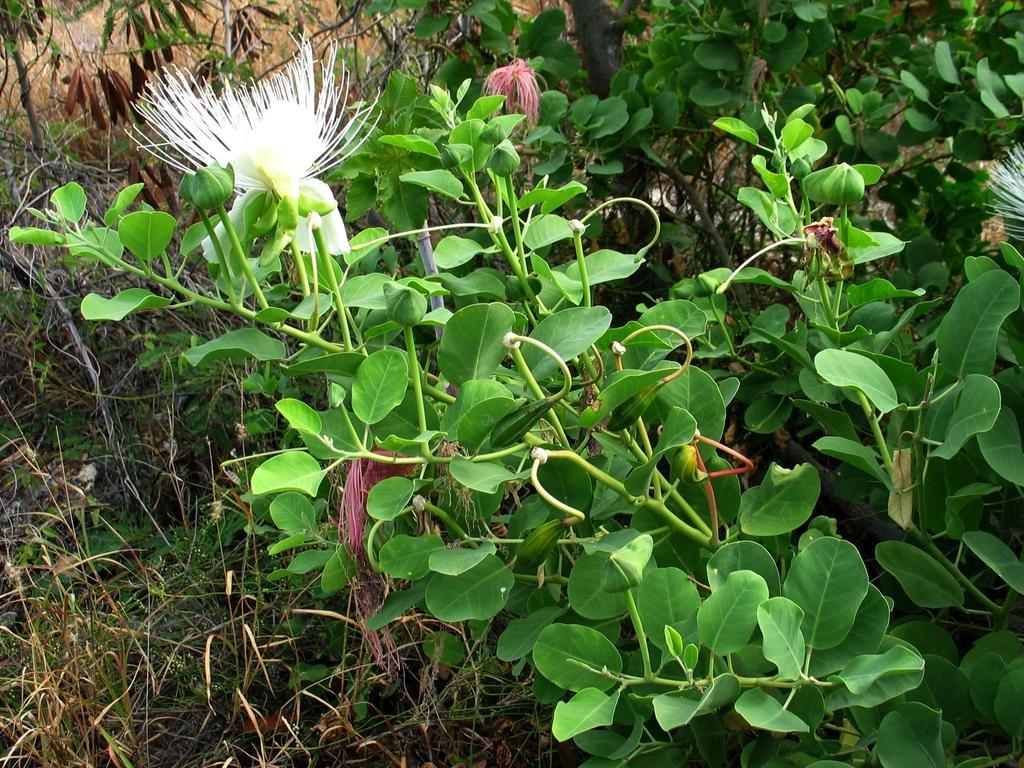In one or two sentences, can you explain what this image depicts? In this image in front there are plants with the flowers on it. At the bottom of the image there is grass on the surface. 